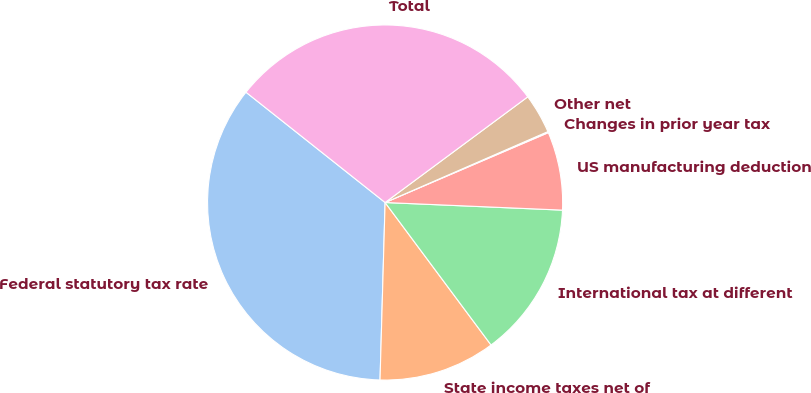Convert chart. <chart><loc_0><loc_0><loc_500><loc_500><pie_chart><fcel>Federal statutory tax rate<fcel>State income taxes net of<fcel>International tax at different<fcel>US manufacturing deduction<fcel>Changes in prior year tax<fcel>Other net<fcel>Total<nl><fcel>35.21%<fcel>10.63%<fcel>14.14%<fcel>7.12%<fcel>0.1%<fcel>3.61%<fcel>29.18%<nl></chart> 